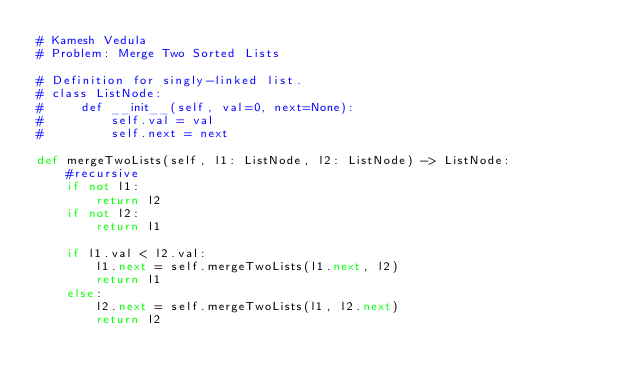Convert code to text. <code><loc_0><loc_0><loc_500><loc_500><_Python_># Kamesh Vedula
# Problem: Merge Two Sorted Lists

# Definition for singly-linked list.
# class ListNode:
#     def __init__(self, val=0, next=None):
#         self.val = val
#         self.next = next

def mergeTwoLists(self, l1: ListNode, l2: ListNode) -> ListNode:
    #recursive
    if not l1:
        return l2
    if not l2:
        return l1
    
    if l1.val < l2.val:
        l1.next = self.mergeTwoLists(l1.next, l2)
        return l1
    else:
        l2.next = self.mergeTwoLists(l1, l2.next)
        return l2</code> 